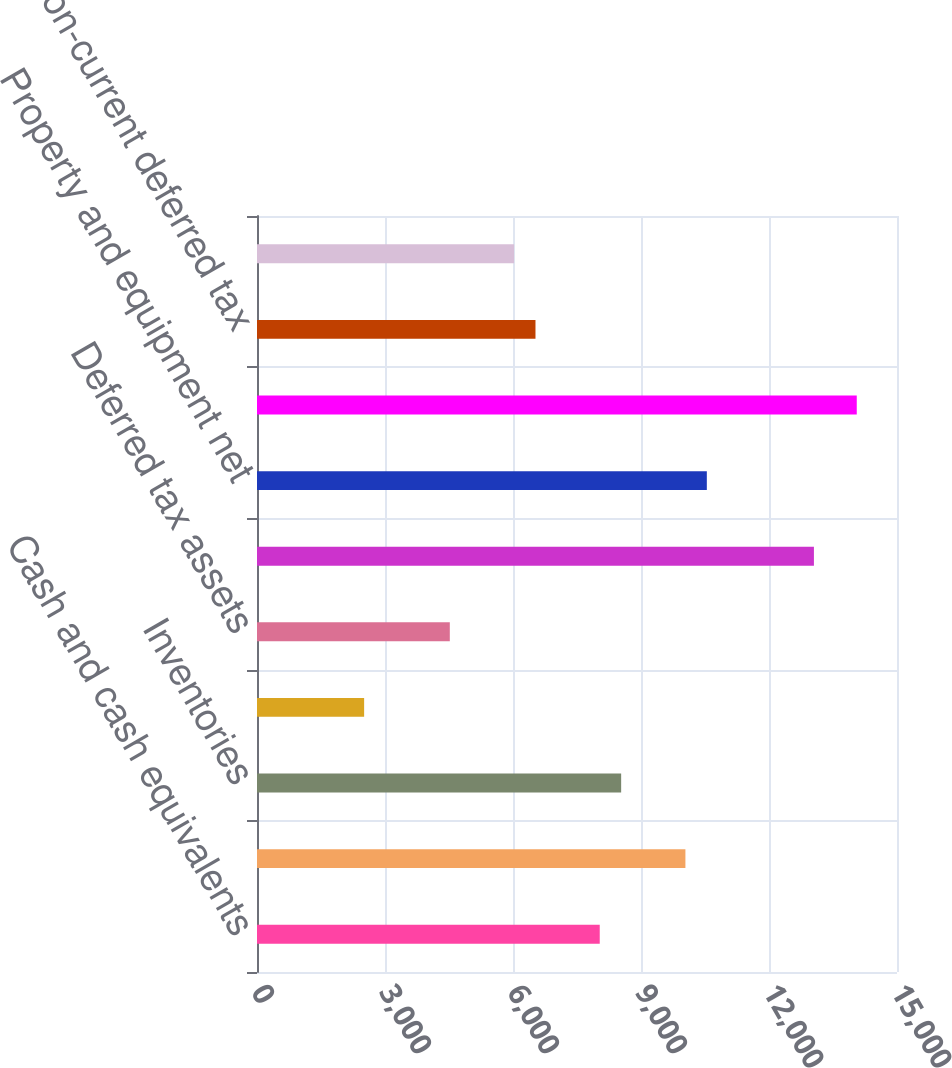<chart> <loc_0><loc_0><loc_500><loc_500><bar_chart><fcel>Cash and cash equivalents<fcel>Receivables net of allowance<fcel>Inventories<fcel>Prepaid expenses and other<fcel>Deferred tax assets<fcel>Total current assets<fcel>Property and equipment net<fcel>Goodwill<fcel>Non-current deferred tax<fcel>Other assets net<nl><fcel>8032.9<fcel>10040.9<fcel>8534.9<fcel>2510.9<fcel>4518.9<fcel>13052.9<fcel>10542.9<fcel>14056.9<fcel>6526.9<fcel>6024.9<nl></chart> 